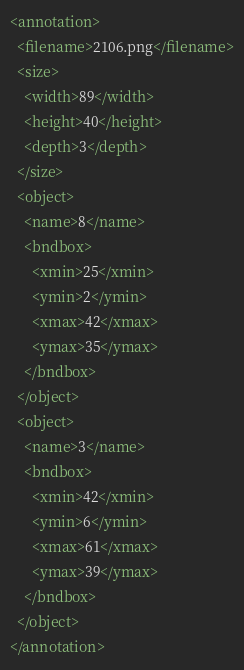<code> <loc_0><loc_0><loc_500><loc_500><_XML_><annotation>
  <filename>2106.png</filename>
  <size>
    <width>89</width>
    <height>40</height>
    <depth>3</depth>
  </size>
  <object>
    <name>8</name>
    <bndbox>
      <xmin>25</xmin>
      <ymin>2</ymin>
      <xmax>42</xmax>
      <ymax>35</ymax>
    </bndbox>
  </object>
  <object>
    <name>3</name>
    <bndbox>
      <xmin>42</xmin>
      <ymin>6</ymin>
      <xmax>61</xmax>
      <ymax>39</ymax>
    </bndbox>
  </object>
</annotation>
</code> 